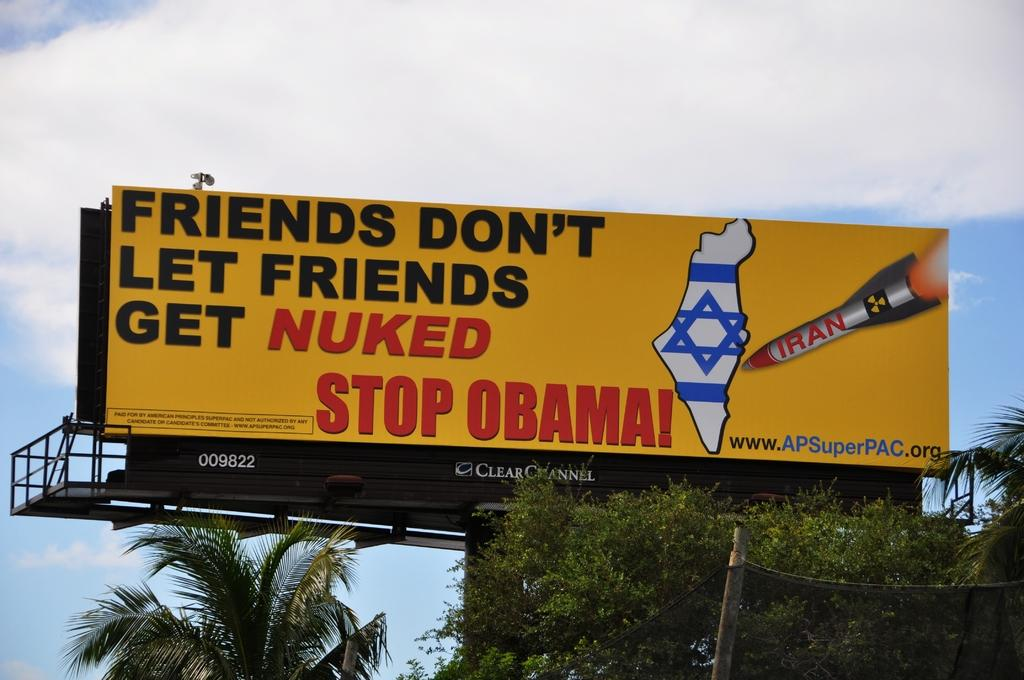<image>
Render a clear and concise summary of the photo. An orange billboard sponsored by APsperpac.org. says, "Stop Obama." 